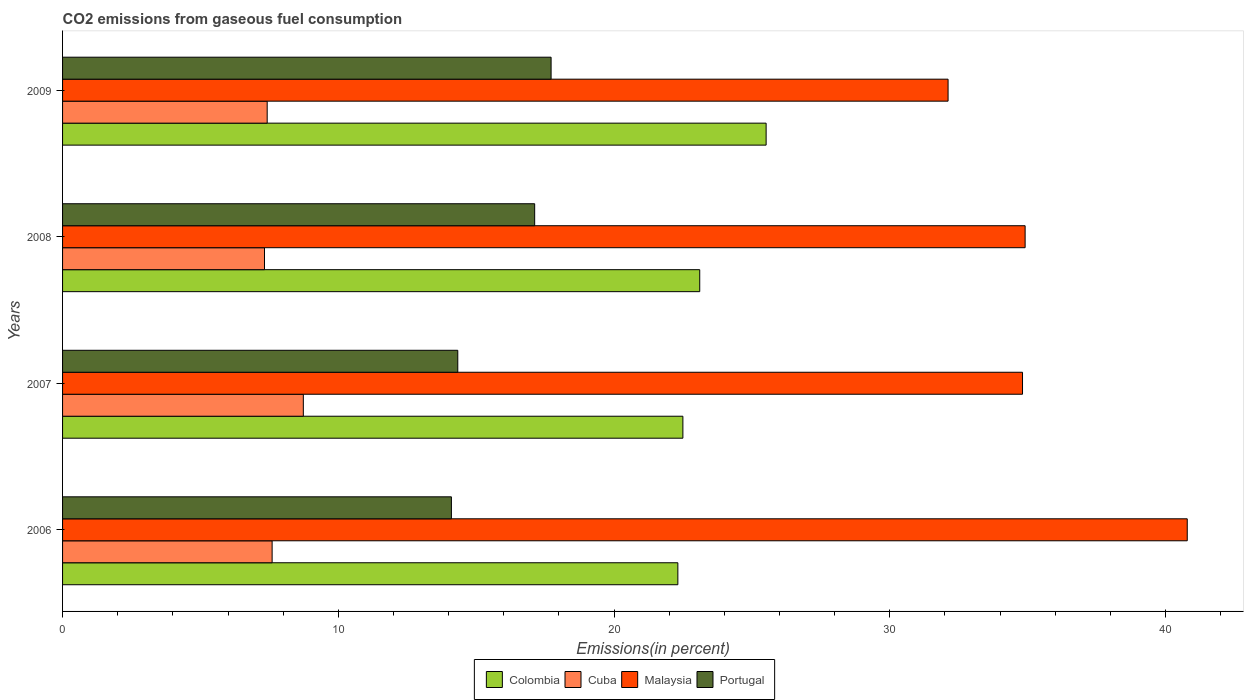Are the number of bars per tick equal to the number of legend labels?
Ensure brevity in your answer.  Yes. How many bars are there on the 1st tick from the bottom?
Keep it short and to the point. 4. What is the label of the 2nd group of bars from the top?
Your answer should be compact. 2008. In how many cases, is the number of bars for a given year not equal to the number of legend labels?
Make the answer very short. 0. What is the total CO2 emitted in Malaysia in 2006?
Make the answer very short. 40.79. Across all years, what is the maximum total CO2 emitted in Portugal?
Give a very brief answer. 17.72. Across all years, what is the minimum total CO2 emitted in Malaysia?
Give a very brief answer. 32.11. What is the total total CO2 emitted in Malaysia in the graph?
Make the answer very short. 142.62. What is the difference between the total CO2 emitted in Malaysia in 2006 and that in 2008?
Offer a terse response. 5.88. What is the difference between the total CO2 emitted in Malaysia in 2009 and the total CO2 emitted in Portugal in 2007?
Offer a very short reply. 17.78. What is the average total CO2 emitted in Cuba per year?
Provide a succinct answer. 7.77. In the year 2009, what is the difference between the total CO2 emitted in Colombia and total CO2 emitted in Malaysia?
Your answer should be very brief. -6.6. In how many years, is the total CO2 emitted in Portugal greater than 28 %?
Your response must be concise. 0. What is the ratio of the total CO2 emitted in Malaysia in 2007 to that in 2008?
Provide a short and direct response. 1. Is the difference between the total CO2 emitted in Colombia in 2006 and 2007 greater than the difference between the total CO2 emitted in Malaysia in 2006 and 2007?
Your answer should be very brief. No. What is the difference between the highest and the second highest total CO2 emitted in Portugal?
Provide a succinct answer. 0.6. What is the difference between the highest and the lowest total CO2 emitted in Colombia?
Keep it short and to the point. 3.2. In how many years, is the total CO2 emitted in Colombia greater than the average total CO2 emitted in Colombia taken over all years?
Ensure brevity in your answer.  1. Is it the case that in every year, the sum of the total CO2 emitted in Cuba and total CO2 emitted in Portugal is greater than the sum of total CO2 emitted in Colombia and total CO2 emitted in Malaysia?
Ensure brevity in your answer.  No. What does the 2nd bar from the top in 2006 represents?
Offer a terse response. Malaysia. What does the 4th bar from the bottom in 2006 represents?
Ensure brevity in your answer.  Portugal. How many years are there in the graph?
Ensure brevity in your answer.  4. What is the difference between two consecutive major ticks on the X-axis?
Give a very brief answer. 10. Where does the legend appear in the graph?
Your response must be concise. Bottom center. How many legend labels are there?
Keep it short and to the point. 4. What is the title of the graph?
Provide a short and direct response. CO2 emissions from gaseous fuel consumption. What is the label or title of the X-axis?
Your answer should be compact. Emissions(in percent). What is the Emissions(in percent) in Colombia in 2006?
Offer a terse response. 22.31. What is the Emissions(in percent) in Cuba in 2006?
Your answer should be compact. 7.6. What is the Emissions(in percent) of Malaysia in 2006?
Offer a terse response. 40.79. What is the Emissions(in percent) in Portugal in 2006?
Offer a very short reply. 14.1. What is the Emissions(in percent) of Colombia in 2007?
Ensure brevity in your answer.  22.5. What is the Emissions(in percent) of Cuba in 2007?
Give a very brief answer. 8.73. What is the Emissions(in percent) of Malaysia in 2007?
Your answer should be compact. 34.81. What is the Emissions(in percent) in Portugal in 2007?
Your response must be concise. 14.33. What is the Emissions(in percent) in Colombia in 2008?
Provide a short and direct response. 23.11. What is the Emissions(in percent) in Cuba in 2008?
Keep it short and to the point. 7.32. What is the Emissions(in percent) of Malaysia in 2008?
Ensure brevity in your answer.  34.91. What is the Emissions(in percent) of Portugal in 2008?
Offer a terse response. 17.12. What is the Emissions(in percent) of Colombia in 2009?
Give a very brief answer. 25.52. What is the Emissions(in percent) of Cuba in 2009?
Give a very brief answer. 7.42. What is the Emissions(in percent) of Malaysia in 2009?
Give a very brief answer. 32.11. What is the Emissions(in percent) in Portugal in 2009?
Offer a very short reply. 17.72. Across all years, what is the maximum Emissions(in percent) in Colombia?
Offer a very short reply. 25.52. Across all years, what is the maximum Emissions(in percent) of Cuba?
Ensure brevity in your answer.  8.73. Across all years, what is the maximum Emissions(in percent) of Malaysia?
Your answer should be compact. 40.79. Across all years, what is the maximum Emissions(in percent) in Portugal?
Make the answer very short. 17.72. Across all years, what is the minimum Emissions(in percent) of Colombia?
Keep it short and to the point. 22.31. Across all years, what is the minimum Emissions(in percent) of Cuba?
Your response must be concise. 7.32. Across all years, what is the minimum Emissions(in percent) of Malaysia?
Provide a succinct answer. 32.11. Across all years, what is the minimum Emissions(in percent) in Portugal?
Keep it short and to the point. 14.1. What is the total Emissions(in percent) in Colombia in the graph?
Your answer should be very brief. 93.43. What is the total Emissions(in percent) in Cuba in the graph?
Make the answer very short. 31.08. What is the total Emissions(in percent) in Malaysia in the graph?
Make the answer very short. 142.62. What is the total Emissions(in percent) of Portugal in the graph?
Offer a very short reply. 63.27. What is the difference between the Emissions(in percent) of Colombia in 2006 and that in 2007?
Provide a succinct answer. -0.18. What is the difference between the Emissions(in percent) of Cuba in 2006 and that in 2007?
Your answer should be very brief. -1.13. What is the difference between the Emissions(in percent) of Malaysia in 2006 and that in 2007?
Give a very brief answer. 5.97. What is the difference between the Emissions(in percent) of Portugal in 2006 and that in 2007?
Make the answer very short. -0.23. What is the difference between the Emissions(in percent) of Colombia in 2006 and that in 2008?
Give a very brief answer. -0.79. What is the difference between the Emissions(in percent) in Cuba in 2006 and that in 2008?
Give a very brief answer. 0.28. What is the difference between the Emissions(in percent) of Malaysia in 2006 and that in 2008?
Offer a terse response. 5.88. What is the difference between the Emissions(in percent) in Portugal in 2006 and that in 2008?
Make the answer very short. -3.02. What is the difference between the Emissions(in percent) in Colombia in 2006 and that in 2009?
Your answer should be very brief. -3.2. What is the difference between the Emissions(in percent) of Cuba in 2006 and that in 2009?
Your answer should be compact. 0.18. What is the difference between the Emissions(in percent) in Malaysia in 2006 and that in 2009?
Give a very brief answer. 8.67. What is the difference between the Emissions(in percent) in Portugal in 2006 and that in 2009?
Provide a succinct answer. -3.62. What is the difference between the Emissions(in percent) of Colombia in 2007 and that in 2008?
Your response must be concise. -0.61. What is the difference between the Emissions(in percent) in Cuba in 2007 and that in 2008?
Your answer should be compact. 1.41. What is the difference between the Emissions(in percent) in Malaysia in 2007 and that in 2008?
Your answer should be very brief. -0.09. What is the difference between the Emissions(in percent) in Portugal in 2007 and that in 2008?
Offer a very short reply. -2.79. What is the difference between the Emissions(in percent) in Colombia in 2007 and that in 2009?
Give a very brief answer. -3.02. What is the difference between the Emissions(in percent) of Cuba in 2007 and that in 2009?
Your response must be concise. 1.31. What is the difference between the Emissions(in percent) of Malaysia in 2007 and that in 2009?
Keep it short and to the point. 2.7. What is the difference between the Emissions(in percent) in Portugal in 2007 and that in 2009?
Ensure brevity in your answer.  -3.38. What is the difference between the Emissions(in percent) in Colombia in 2008 and that in 2009?
Offer a terse response. -2.41. What is the difference between the Emissions(in percent) in Cuba in 2008 and that in 2009?
Keep it short and to the point. -0.1. What is the difference between the Emissions(in percent) in Malaysia in 2008 and that in 2009?
Offer a terse response. 2.79. What is the difference between the Emissions(in percent) of Portugal in 2008 and that in 2009?
Your response must be concise. -0.6. What is the difference between the Emissions(in percent) of Colombia in 2006 and the Emissions(in percent) of Cuba in 2007?
Make the answer very short. 13.58. What is the difference between the Emissions(in percent) in Colombia in 2006 and the Emissions(in percent) in Malaysia in 2007?
Give a very brief answer. -12.5. What is the difference between the Emissions(in percent) in Colombia in 2006 and the Emissions(in percent) in Portugal in 2007?
Offer a terse response. 7.98. What is the difference between the Emissions(in percent) in Cuba in 2006 and the Emissions(in percent) in Malaysia in 2007?
Provide a short and direct response. -27.21. What is the difference between the Emissions(in percent) of Cuba in 2006 and the Emissions(in percent) of Portugal in 2007?
Keep it short and to the point. -6.73. What is the difference between the Emissions(in percent) of Malaysia in 2006 and the Emissions(in percent) of Portugal in 2007?
Give a very brief answer. 26.45. What is the difference between the Emissions(in percent) in Colombia in 2006 and the Emissions(in percent) in Cuba in 2008?
Give a very brief answer. 14.99. What is the difference between the Emissions(in percent) of Colombia in 2006 and the Emissions(in percent) of Malaysia in 2008?
Give a very brief answer. -12.59. What is the difference between the Emissions(in percent) of Colombia in 2006 and the Emissions(in percent) of Portugal in 2008?
Make the answer very short. 5.19. What is the difference between the Emissions(in percent) of Cuba in 2006 and the Emissions(in percent) of Malaysia in 2008?
Your answer should be very brief. -27.31. What is the difference between the Emissions(in percent) of Cuba in 2006 and the Emissions(in percent) of Portugal in 2008?
Offer a very short reply. -9.52. What is the difference between the Emissions(in percent) of Malaysia in 2006 and the Emissions(in percent) of Portugal in 2008?
Offer a terse response. 23.67. What is the difference between the Emissions(in percent) of Colombia in 2006 and the Emissions(in percent) of Cuba in 2009?
Offer a very short reply. 14.89. What is the difference between the Emissions(in percent) in Colombia in 2006 and the Emissions(in percent) in Malaysia in 2009?
Offer a terse response. -9.8. What is the difference between the Emissions(in percent) of Colombia in 2006 and the Emissions(in percent) of Portugal in 2009?
Your answer should be compact. 4.6. What is the difference between the Emissions(in percent) in Cuba in 2006 and the Emissions(in percent) in Malaysia in 2009?
Give a very brief answer. -24.51. What is the difference between the Emissions(in percent) in Cuba in 2006 and the Emissions(in percent) in Portugal in 2009?
Keep it short and to the point. -10.12. What is the difference between the Emissions(in percent) in Malaysia in 2006 and the Emissions(in percent) in Portugal in 2009?
Give a very brief answer. 23.07. What is the difference between the Emissions(in percent) of Colombia in 2007 and the Emissions(in percent) of Cuba in 2008?
Make the answer very short. 15.17. What is the difference between the Emissions(in percent) of Colombia in 2007 and the Emissions(in percent) of Malaysia in 2008?
Offer a very short reply. -12.41. What is the difference between the Emissions(in percent) in Colombia in 2007 and the Emissions(in percent) in Portugal in 2008?
Provide a short and direct response. 5.37. What is the difference between the Emissions(in percent) of Cuba in 2007 and the Emissions(in percent) of Malaysia in 2008?
Your answer should be very brief. -26.18. What is the difference between the Emissions(in percent) in Cuba in 2007 and the Emissions(in percent) in Portugal in 2008?
Make the answer very short. -8.39. What is the difference between the Emissions(in percent) in Malaysia in 2007 and the Emissions(in percent) in Portugal in 2008?
Keep it short and to the point. 17.69. What is the difference between the Emissions(in percent) in Colombia in 2007 and the Emissions(in percent) in Cuba in 2009?
Your answer should be compact. 15.08. What is the difference between the Emissions(in percent) in Colombia in 2007 and the Emissions(in percent) in Malaysia in 2009?
Your answer should be compact. -9.62. What is the difference between the Emissions(in percent) in Colombia in 2007 and the Emissions(in percent) in Portugal in 2009?
Your answer should be compact. 4.78. What is the difference between the Emissions(in percent) in Cuba in 2007 and the Emissions(in percent) in Malaysia in 2009?
Offer a very short reply. -23.38. What is the difference between the Emissions(in percent) of Cuba in 2007 and the Emissions(in percent) of Portugal in 2009?
Offer a terse response. -8.99. What is the difference between the Emissions(in percent) in Malaysia in 2007 and the Emissions(in percent) in Portugal in 2009?
Your answer should be very brief. 17.1. What is the difference between the Emissions(in percent) of Colombia in 2008 and the Emissions(in percent) of Cuba in 2009?
Offer a terse response. 15.69. What is the difference between the Emissions(in percent) in Colombia in 2008 and the Emissions(in percent) in Malaysia in 2009?
Your answer should be compact. -9.01. What is the difference between the Emissions(in percent) of Colombia in 2008 and the Emissions(in percent) of Portugal in 2009?
Keep it short and to the point. 5.39. What is the difference between the Emissions(in percent) of Cuba in 2008 and the Emissions(in percent) of Malaysia in 2009?
Your answer should be very brief. -24.79. What is the difference between the Emissions(in percent) in Cuba in 2008 and the Emissions(in percent) in Portugal in 2009?
Keep it short and to the point. -10.39. What is the difference between the Emissions(in percent) in Malaysia in 2008 and the Emissions(in percent) in Portugal in 2009?
Offer a very short reply. 17.19. What is the average Emissions(in percent) of Colombia per year?
Ensure brevity in your answer.  23.36. What is the average Emissions(in percent) of Cuba per year?
Ensure brevity in your answer.  7.77. What is the average Emissions(in percent) in Malaysia per year?
Offer a very short reply. 35.66. What is the average Emissions(in percent) in Portugal per year?
Provide a short and direct response. 15.82. In the year 2006, what is the difference between the Emissions(in percent) of Colombia and Emissions(in percent) of Cuba?
Ensure brevity in your answer.  14.71. In the year 2006, what is the difference between the Emissions(in percent) of Colombia and Emissions(in percent) of Malaysia?
Your response must be concise. -18.47. In the year 2006, what is the difference between the Emissions(in percent) in Colombia and Emissions(in percent) in Portugal?
Your answer should be very brief. 8.21. In the year 2006, what is the difference between the Emissions(in percent) of Cuba and Emissions(in percent) of Malaysia?
Provide a short and direct response. -33.19. In the year 2006, what is the difference between the Emissions(in percent) in Cuba and Emissions(in percent) in Portugal?
Keep it short and to the point. -6.5. In the year 2006, what is the difference between the Emissions(in percent) in Malaysia and Emissions(in percent) in Portugal?
Ensure brevity in your answer.  26.69. In the year 2007, what is the difference between the Emissions(in percent) of Colombia and Emissions(in percent) of Cuba?
Give a very brief answer. 13.77. In the year 2007, what is the difference between the Emissions(in percent) in Colombia and Emissions(in percent) in Malaysia?
Make the answer very short. -12.32. In the year 2007, what is the difference between the Emissions(in percent) of Colombia and Emissions(in percent) of Portugal?
Provide a succinct answer. 8.16. In the year 2007, what is the difference between the Emissions(in percent) in Cuba and Emissions(in percent) in Malaysia?
Give a very brief answer. -26.08. In the year 2007, what is the difference between the Emissions(in percent) of Cuba and Emissions(in percent) of Portugal?
Your answer should be compact. -5.6. In the year 2007, what is the difference between the Emissions(in percent) of Malaysia and Emissions(in percent) of Portugal?
Your answer should be compact. 20.48. In the year 2008, what is the difference between the Emissions(in percent) in Colombia and Emissions(in percent) in Cuba?
Keep it short and to the point. 15.78. In the year 2008, what is the difference between the Emissions(in percent) of Colombia and Emissions(in percent) of Malaysia?
Provide a short and direct response. -11.8. In the year 2008, what is the difference between the Emissions(in percent) in Colombia and Emissions(in percent) in Portugal?
Provide a succinct answer. 5.99. In the year 2008, what is the difference between the Emissions(in percent) in Cuba and Emissions(in percent) in Malaysia?
Give a very brief answer. -27.58. In the year 2008, what is the difference between the Emissions(in percent) in Cuba and Emissions(in percent) in Portugal?
Your response must be concise. -9.8. In the year 2008, what is the difference between the Emissions(in percent) of Malaysia and Emissions(in percent) of Portugal?
Your answer should be very brief. 17.79. In the year 2009, what is the difference between the Emissions(in percent) in Colombia and Emissions(in percent) in Cuba?
Provide a succinct answer. 18.09. In the year 2009, what is the difference between the Emissions(in percent) of Colombia and Emissions(in percent) of Malaysia?
Make the answer very short. -6.6. In the year 2009, what is the difference between the Emissions(in percent) of Colombia and Emissions(in percent) of Portugal?
Give a very brief answer. 7.8. In the year 2009, what is the difference between the Emissions(in percent) in Cuba and Emissions(in percent) in Malaysia?
Offer a very short reply. -24.69. In the year 2009, what is the difference between the Emissions(in percent) in Cuba and Emissions(in percent) in Portugal?
Give a very brief answer. -10.3. In the year 2009, what is the difference between the Emissions(in percent) in Malaysia and Emissions(in percent) in Portugal?
Offer a very short reply. 14.4. What is the ratio of the Emissions(in percent) in Colombia in 2006 to that in 2007?
Your response must be concise. 0.99. What is the ratio of the Emissions(in percent) of Cuba in 2006 to that in 2007?
Offer a very short reply. 0.87. What is the ratio of the Emissions(in percent) in Malaysia in 2006 to that in 2007?
Provide a succinct answer. 1.17. What is the ratio of the Emissions(in percent) in Portugal in 2006 to that in 2007?
Offer a very short reply. 0.98. What is the ratio of the Emissions(in percent) of Colombia in 2006 to that in 2008?
Your response must be concise. 0.97. What is the ratio of the Emissions(in percent) of Cuba in 2006 to that in 2008?
Ensure brevity in your answer.  1.04. What is the ratio of the Emissions(in percent) in Malaysia in 2006 to that in 2008?
Offer a very short reply. 1.17. What is the ratio of the Emissions(in percent) of Portugal in 2006 to that in 2008?
Give a very brief answer. 0.82. What is the ratio of the Emissions(in percent) in Colombia in 2006 to that in 2009?
Ensure brevity in your answer.  0.87. What is the ratio of the Emissions(in percent) in Cuba in 2006 to that in 2009?
Give a very brief answer. 1.02. What is the ratio of the Emissions(in percent) in Malaysia in 2006 to that in 2009?
Your answer should be very brief. 1.27. What is the ratio of the Emissions(in percent) of Portugal in 2006 to that in 2009?
Offer a very short reply. 0.8. What is the ratio of the Emissions(in percent) of Colombia in 2007 to that in 2008?
Your response must be concise. 0.97. What is the ratio of the Emissions(in percent) of Cuba in 2007 to that in 2008?
Your response must be concise. 1.19. What is the ratio of the Emissions(in percent) of Malaysia in 2007 to that in 2008?
Give a very brief answer. 1. What is the ratio of the Emissions(in percent) of Portugal in 2007 to that in 2008?
Offer a very short reply. 0.84. What is the ratio of the Emissions(in percent) of Colombia in 2007 to that in 2009?
Your answer should be very brief. 0.88. What is the ratio of the Emissions(in percent) in Cuba in 2007 to that in 2009?
Keep it short and to the point. 1.18. What is the ratio of the Emissions(in percent) of Malaysia in 2007 to that in 2009?
Your response must be concise. 1.08. What is the ratio of the Emissions(in percent) of Portugal in 2007 to that in 2009?
Ensure brevity in your answer.  0.81. What is the ratio of the Emissions(in percent) of Colombia in 2008 to that in 2009?
Offer a very short reply. 0.91. What is the ratio of the Emissions(in percent) in Cuba in 2008 to that in 2009?
Your answer should be compact. 0.99. What is the ratio of the Emissions(in percent) of Malaysia in 2008 to that in 2009?
Give a very brief answer. 1.09. What is the ratio of the Emissions(in percent) of Portugal in 2008 to that in 2009?
Ensure brevity in your answer.  0.97. What is the difference between the highest and the second highest Emissions(in percent) of Colombia?
Provide a succinct answer. 2.41. What is the difference between the highest and the second highest Emissions(in percent) in Cuba?
Offer a very short reply. 1.13. What is the difference between the highest and the second highest Emissions(in percent) in Malaysia?
Provide a short and direct response. 5.88. What is the difference between the highest and the second highest Emissions(in percent) of Portugal?
Make the answer very short. 0.6. What is the difference between the highest and the lowest Emissions(in percent) in Colombia?
Make the answer very short. 3.2. What is the difference between the highest and the lowest Emissions(in percent) of Cuba?
Offer a very short reply. 1.41. What is the difference between the highest and the lowest Emissions(in percent) in Malaysia?
Ensure brevity in your answer.  8.67. What is the difference between the highest and the lowest Emissions(in percent) of Portugal?
Provide a succinct answer. 3.62. 